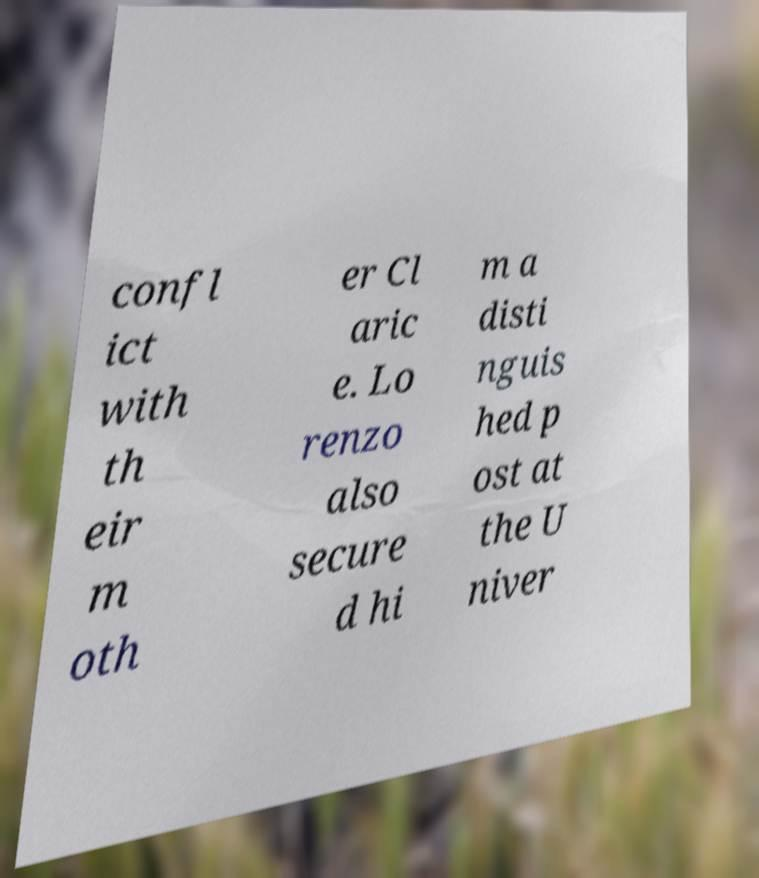For documentation purposes, I need the text within this image transcribed. Could you provide that? confl ict with th eir m oth er Cl aric e. Lo renzo also secure d hi m a disti nguis hed p ost at the U niver 